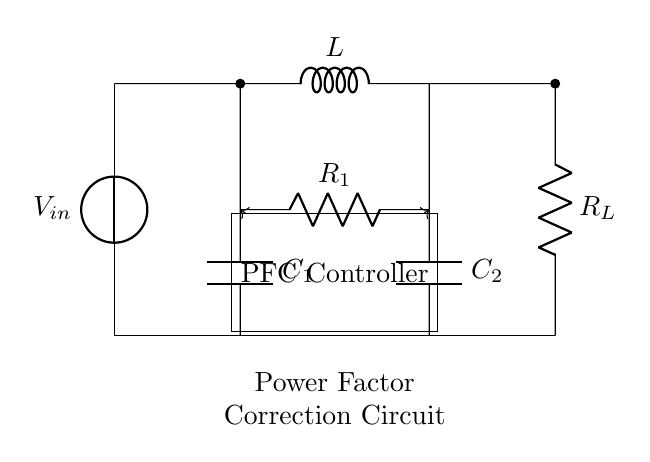What is the input voltage of the circuit? The circuit shows a voltage source labeled V-in, indicating the input voltage. The specific value is not provided but is identified as V-in in the diagram.
Answer: V-in How many capacitors are present in the circuit? The circuit diagram includes two capacitors labeled C1 and C2. By counting these components, we find that the total is two capacitors.
Answer: 2 What is the role of the PFC controller? The Power Factor Correction (PFC) controller's role is to manage and optimize the consumption of reactive power, ensuring the circuit operates efficiently. It influences both capacitors' operation as depicted by the arrows leading to them.
Answer: Manage power factor What does the R-L component represent in the circuit? R-L indicates a resistive load where R-L specifically represents a resistor. The context of the circuit suggests it is the load that the power factor correction aims to optimize.
Answer: Resistor What is the primary purpose of this power factor correction circuit? The primary purpose of a power factor correction circuit is to improve energy efficiency by minimizing the phase difference between voltage and current, thereby reducing electricity costs related to reactive power consumption.
Answer: Improve efficiency Which components are used in parallel with R-L? The capacitors C1 and C2 are connected in parallel with the resistive load R-L. This is determined by their direct connection across the same voltage nodes as R-L.
Answer: C1 and C2 